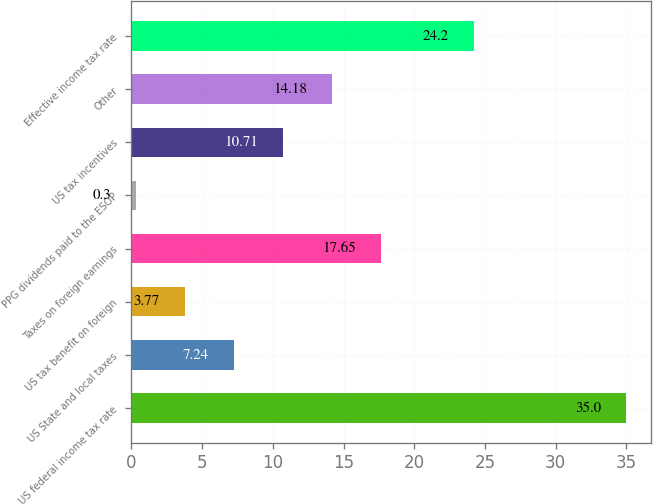<chart> <loc_0><loc_0><loc_500><loc_500><bar_chart><fcel>US federal income tax rate<fcel>US State and local taxes<fcel>US tax benefit on foreign<fcel>Taxes on foreign earnings<fcel>PPG dividends paid to the ESOP<fcel>US tax incentives<fcel>Other<fcel>Effective income tax rate<nl><fcel>35<fcel>7.24<fcel>3.77<fcel>17.65<fcel>0.3<fcel>10.71<fcel>14.18<fcel>24.2<nl></chart> 